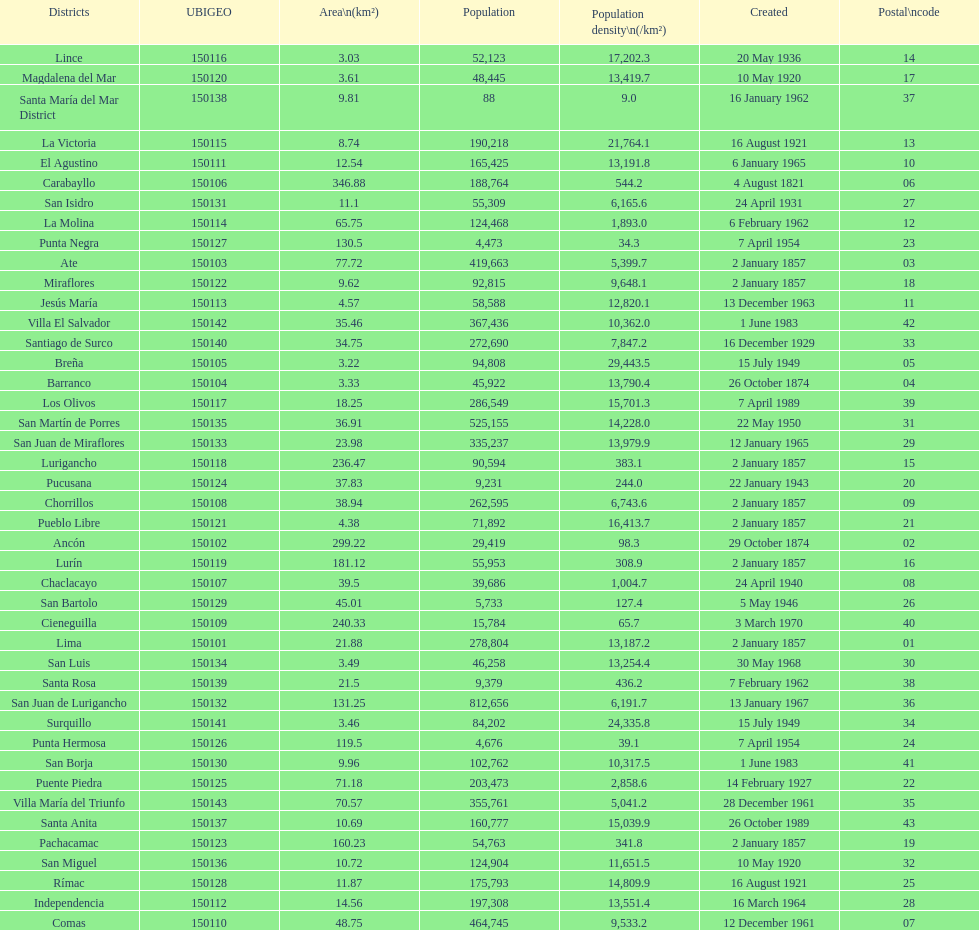How many districts have more than 100,000 people in this city? 21. 